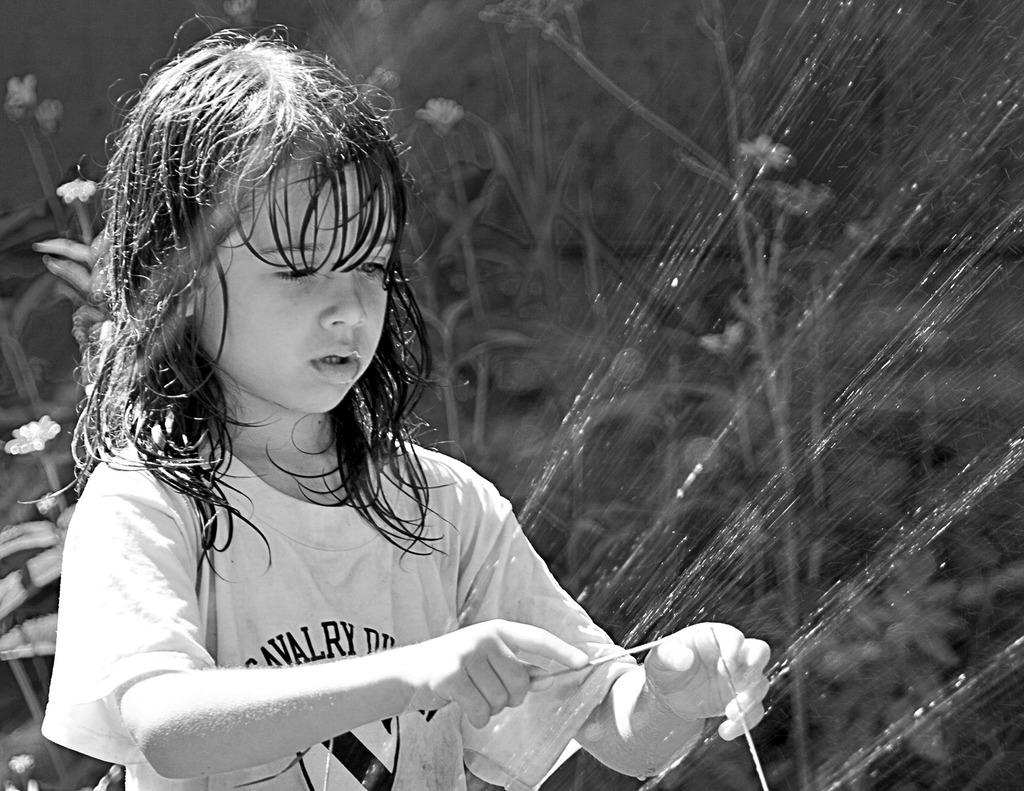What is the color scheme of the image? The image is black and white. What can be seen in the image besides the color scheme? There is a girl standing in the image, as well as plants and water. What type of magic is the girl performing with the plate in the image? There is no plate present in the image, and the girl is not performing any magic. 